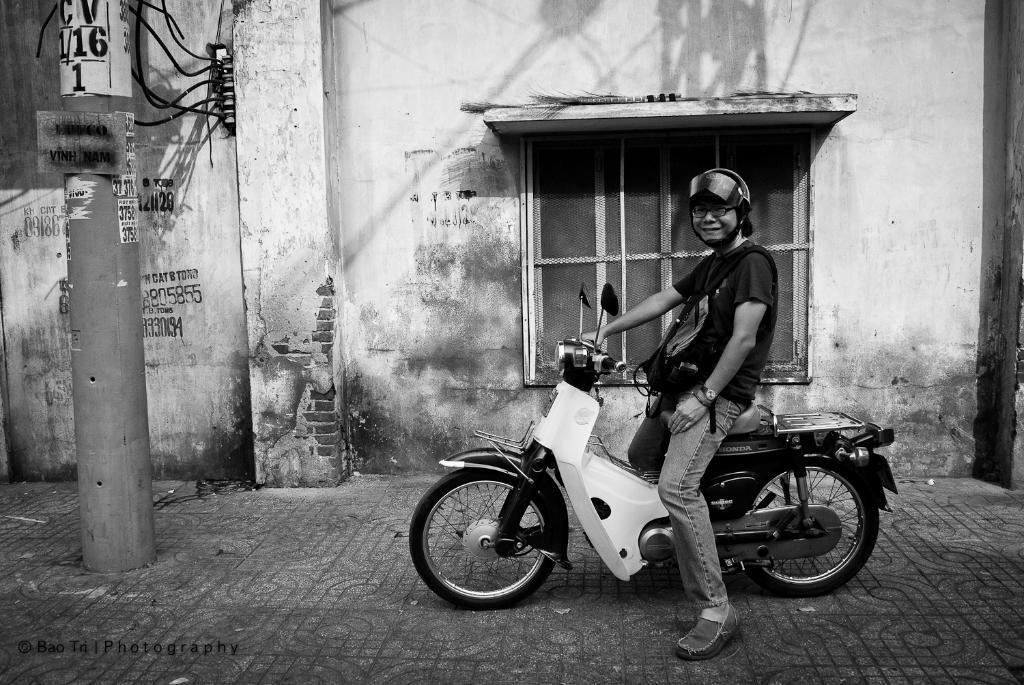Can you describe this image briefly? A black and white picture. This man is sitting on a motorbike and wore helmet. This building is with window. In-front of this building there is a current pole. 